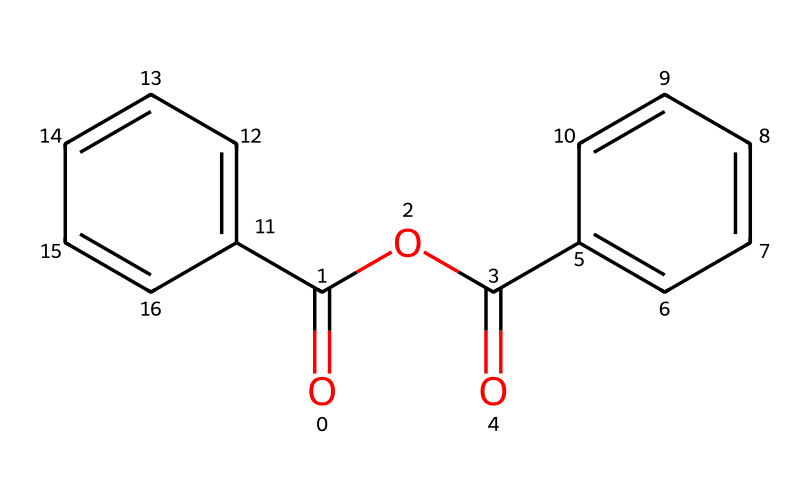What is the molecular formula of benzoic anhydride? To find the molecular formula, we count all carbon (C), hydrogen (H), and oxygen (O) atoms in the SMILES. There are 15 carbon atoms, 10 hydrogen atoms, and 3 oxygen atoms, giving the formula C15H10O3.
Answer: C15H10O3 How many rings are present in the structure? The structure contains two benzene rings, each forming a cyclic structure with alternating double bonds. Counting these rings gives a total of 2 rings.
Answer: 2 What type of functional groups are present in benzoic anhydride? Upon examining the structure, we can identify carbonyl groups (C=O) and an ether linkage (C-O-C). The presence of both carbonyls and ethers indicates the functional groups present.
Answer: carbonyl and ether What is the degree of unsaturation in benzoic anhydride? The degree of unsaturation can be calculated by counting rings and pi bonds. Each benzene ring contributes one unit of unsaturation, and the two carbonyls contribute one each. This results in a degree of unsaturation of 6.
Answer: 6 Does benzoic anhydride contain any chiral centers? A chiral center requires a carbon atom to be bonded to four different substituents, which we can inspect in the structure. All carbon atoms in this compound are either part of benzene rings or attached to identical substituents, confirming no chiral centers exist.
Answer: no What chemical class does benzoic anhydride belong to? Based on its molecular structure and functional groups, benzoic anhydride is classified as an acid anhydride, specifically derived from benzoic acid. This identification is due to its formation from two carboxylic acid molecules through dehydration.
Answer: acid anhydride 